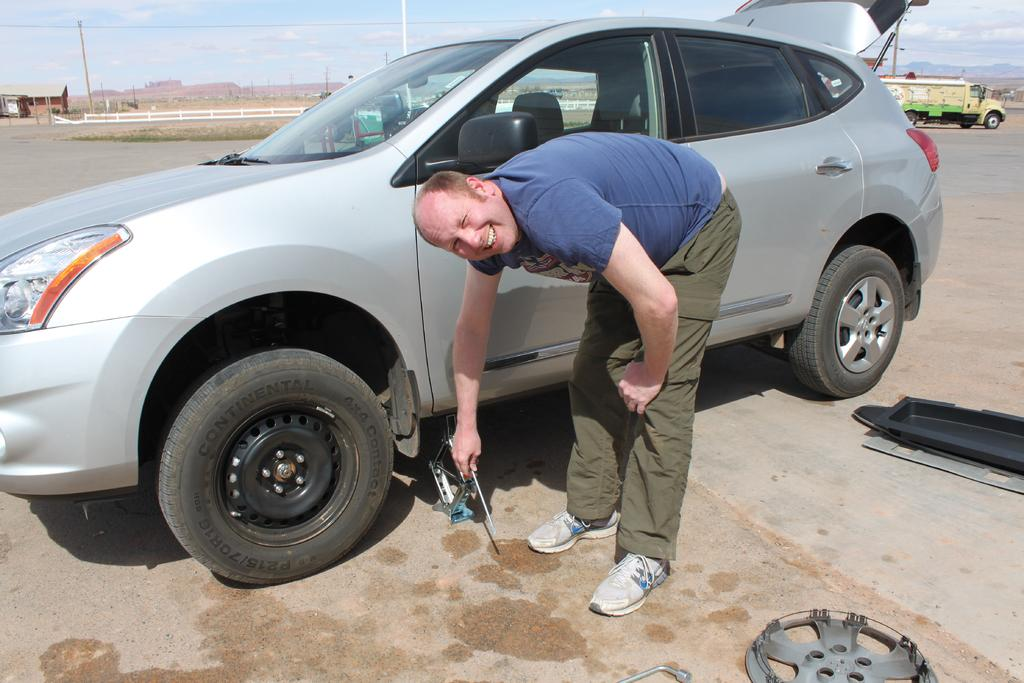What is the person in the image doing? The person is standing in the image and holding an object. What can be seen in the image besides the person? There is a car, a rim, a house, and the sky visible in the image. Where is the car located in the image? The car is on the road in the image. What is the rim associated with in the image? The rim is associated with the car in the image. What type of cannon is being used to launch the box in the image? There is no cannon or box present in the image. What is the base of the car in the image? The image does not show the base of the car; it only shows the car on the road. 